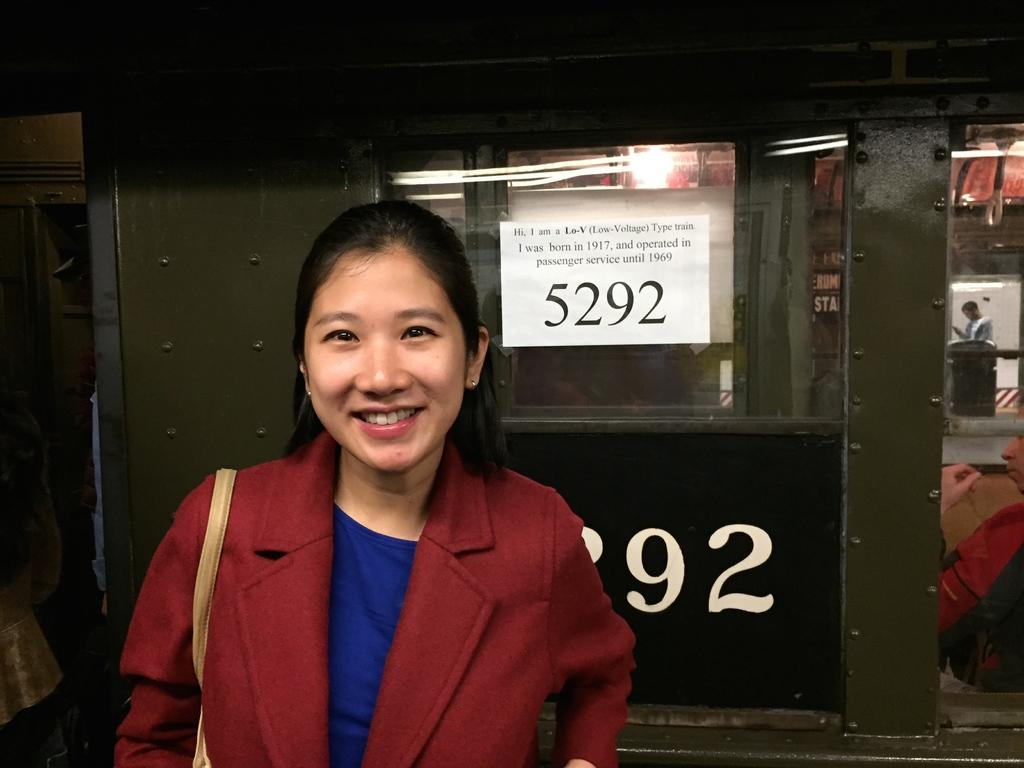Who is present in the image? There is a lady in the image. What is the lady wearing? The lady is wearing a coat. What is the lady's facial expression? The lady is smiling. What accessory does the lady have? There is a handbag with the lady. What can be seen in the background of the image? There is a wall in the background of the image, and there is a poster on the wall. Can you identify any numbers in the image? Yes, there is a number visible on the wall or poster. Who else is present in the image? There is a person on the right side of the image. What type of glove is the lady wearing in the image? The lady is not wearing a glove in the image; she is wearing a coat. How many bushes can be seen in the image? There are no bushes present in the image; it features a lady, a wall, a poster, and a number. 